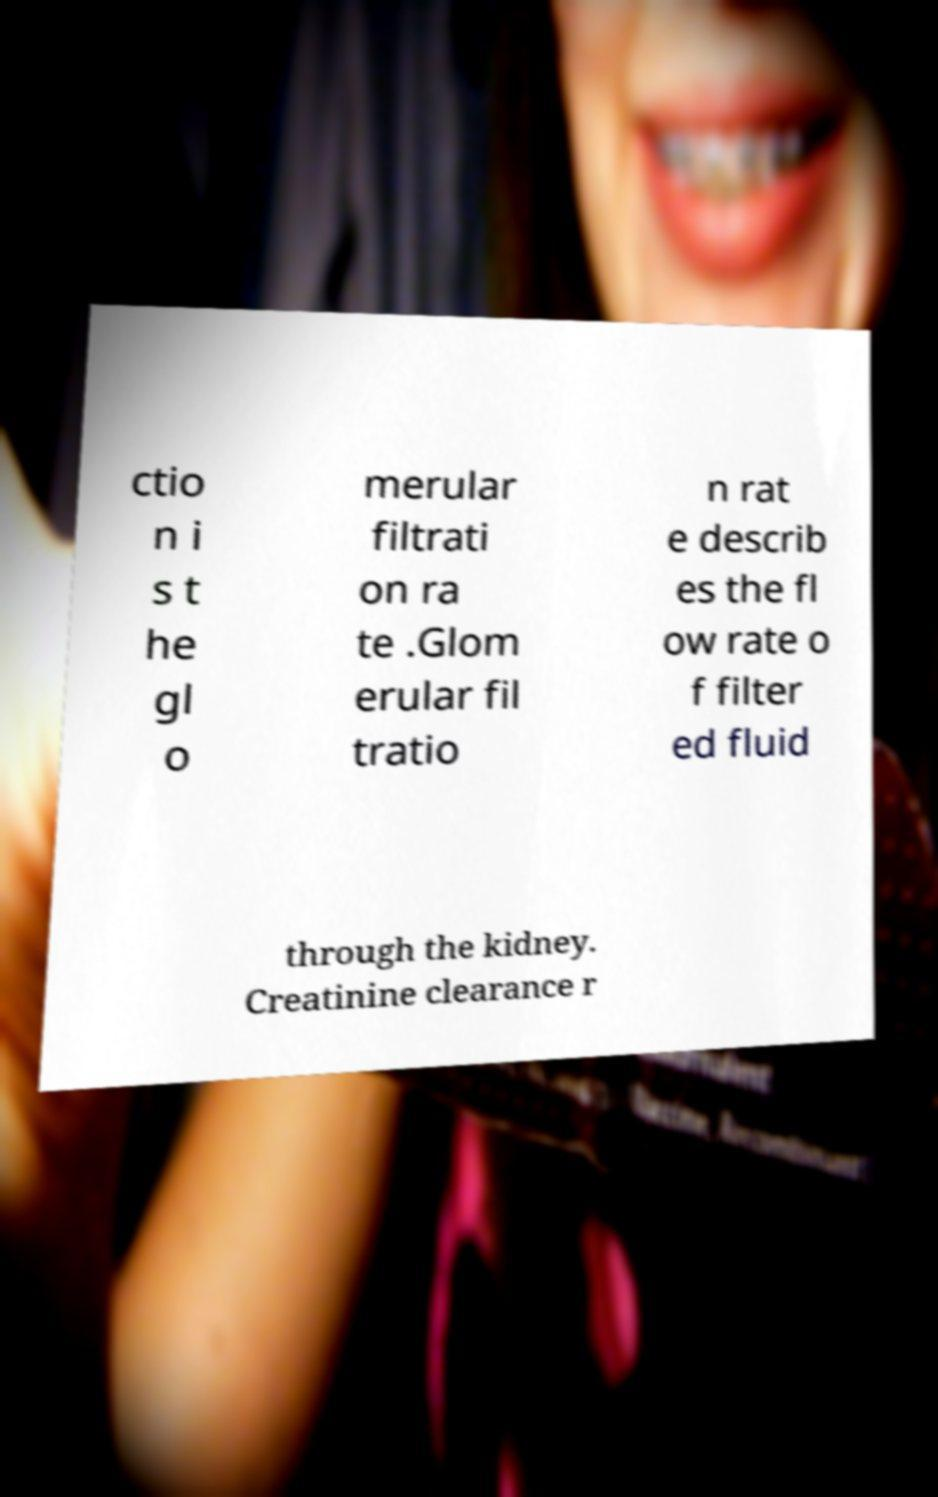Could you assist in decoding the text presented in this image and type it out clearly? ctio n i s t he gl o merular filtrati on ra te .Glom erular fil tratio n rat e describ es the fl ow rate o f filter ed fluid through the kidney. Creatinine clearance r 